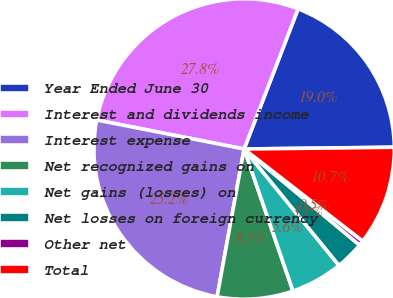Convert chart to OTSL. <chart><loc_0><loc_0><loc_500><loc_500><pie_chart><fcel>Year Ended June 30<fcel>Interest and dividends income<fcel>Interest expense<fcel>Net recognized gains on<fcel>Net gains (losses) on<fcel>Net losses on foreign currency<fcel>Other net<fcel>Total<nl><fcel>18.96%<fcel>27.76%<fcel>25.22%<fcel>8.15%<fcel>5.61%<fcel>3.07%<fcel>0.54%<fcel>10.69%<nl></chart> 